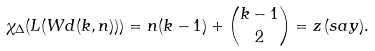Convert formula to latex. <formula><loc_0><loc_0><loc_500><loc_500>\chi _ { \Delta } ( L ( W d ( k , n ) ) ) = n ( k - 1 ) + \binom { k - 1 } { 2 } = z \, ( s a y ) .</formula> 